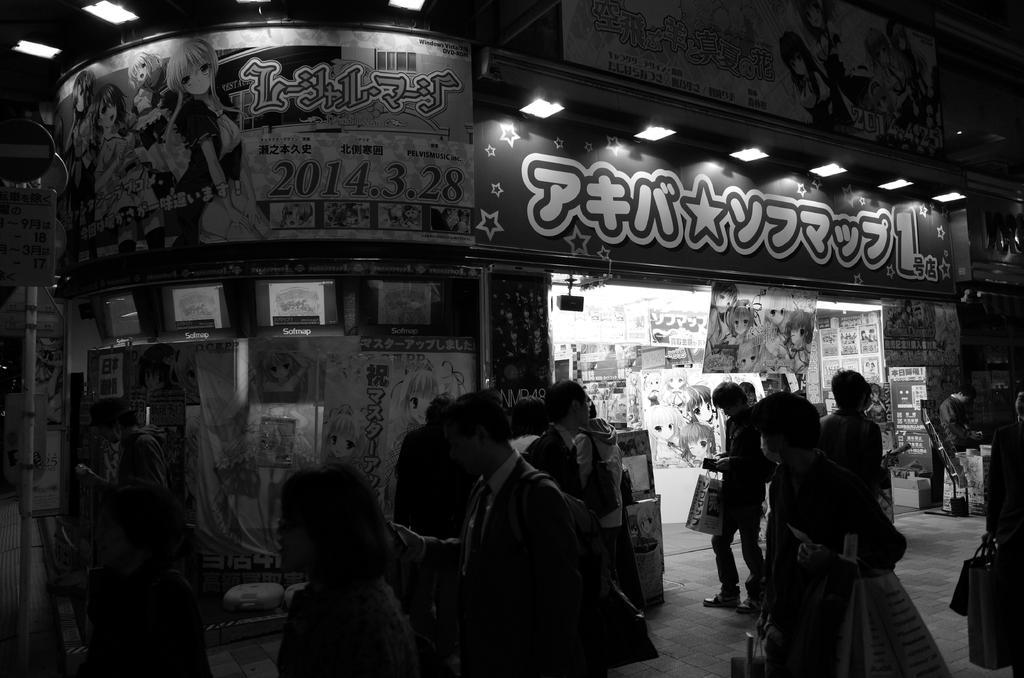Please provide a concise description of this image. In this image there is a store and we can see boards. At the top there are lights. We can see people. On the left there is a sign board. There are posters pasted on the walls. 